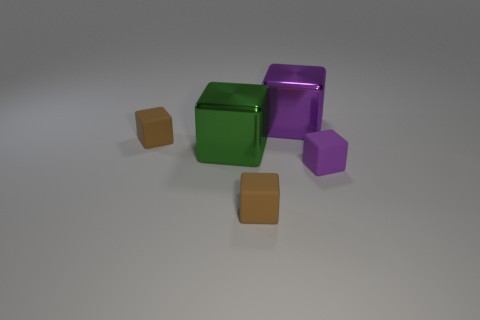The green thing is what size?
Make the answer very short. Large. Are there more small purple cubes to the left of the green thing than cubes that are behind the large purple metal object?
Provide a succinct answer. No. Are there more tiny matte cubes than cubes?
Provide a succinct answer. No. How big is the cube that is in front of the green object and on the left side of the purple matte object?
Ensure brevity in your answer.  Small. The big green shiny object is what shape?
Keep it short and to the point. Cube. Are there more blocks right of the large green block than large green metallic blocks?
Keep it short and to the point. Yes. There is a small brown matte object that is behind the tiny brown rubber thing that is in front of the brown block behind the small purple block; what is its shape?
Ensure brevity in your answer.  Cube. There is a brown rubber block that is on the left side of the green thing; does it have the same size as the green metal thing?
Offer a very short reply. No. What shape is the matte object that is to the right of the green object and on the left side of the tiny purple thing?
Keep it short and to the point. Cube. There is a big metal object that is behind the brown object behind the small brown rubber object in front of the green block; what is its color?
Ensure brevity in your answer.  Purple. 